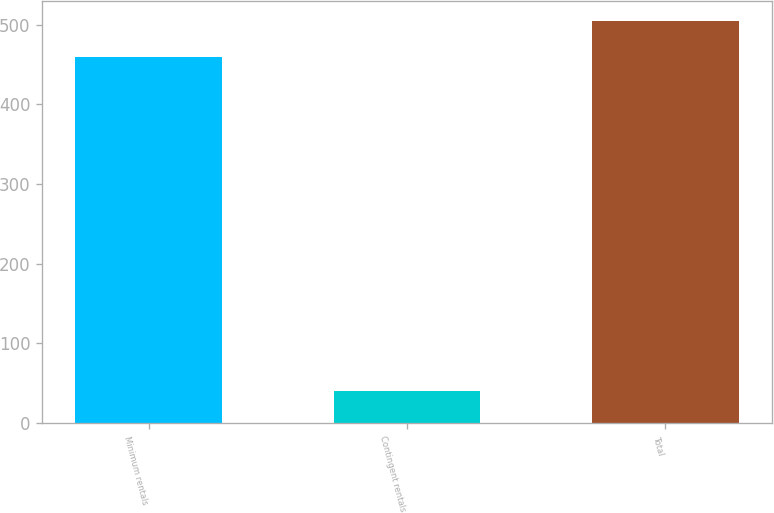Convert chart. <chart><loc_0><loc_0><loc_500><loc_500><bar_chart><fcel>Minimum rentals<fcel>Contingent rentals<fcel>Total<nl><fcel>458.7<fcel>40.1<fcel>504.57<nl></chart> 